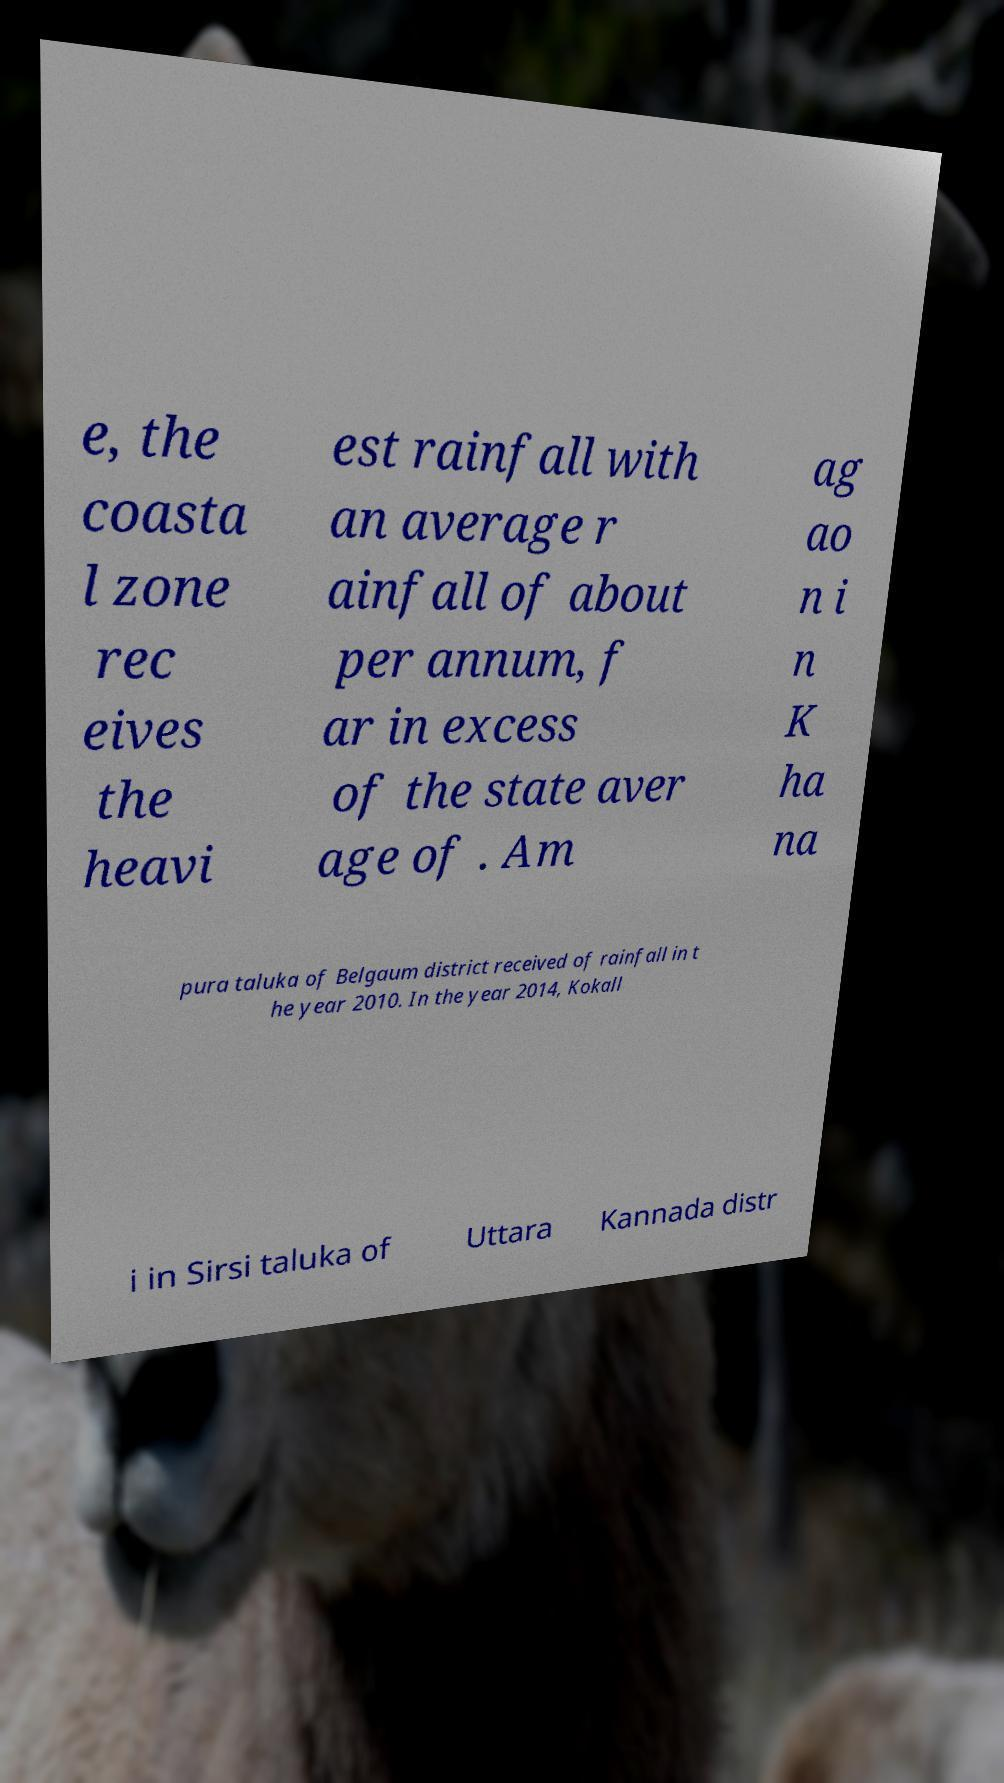Can you accurately transcribe the text from the provided image for me? e, the coasta l zone rec eives the heavi est rainfall with an average r ainfall of about per annum, f ar in excess of the state aver age of . Am ag ao n i n K ha na pura taluka of Belgaum district received of rainfall in t he year 2010. In the year 2014, Kokall i in Sirsi taluka of Uttara Kannada distr 